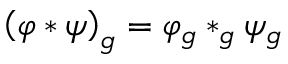<formula> <loc_0><loc_0><loc_500><loc_500>\left ( \varphi * \psi \right ) _ { g } = \varphi _ { g } * _ { g } \psi _ { g }</formula> 